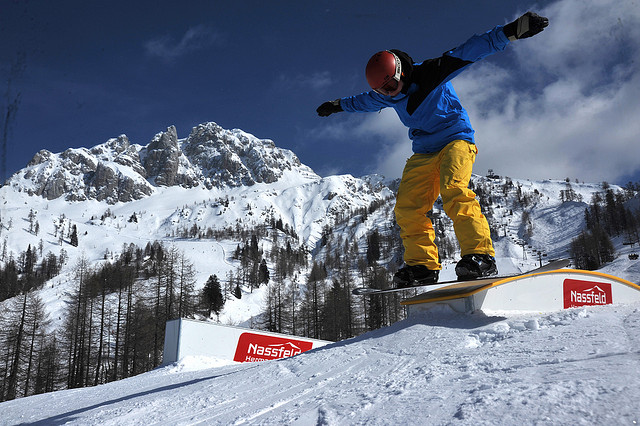What is the historical significance of this snowboarding location? This snowboarding location holds a rich history dating back to the ancient tribes that once called these mountains home. The steep, snow-covered slopes are believed to be enchanted, used for centuries as sacred grounds where warriors would train and compete in trials of endurance and bravery. Over time, the tradition evolved into more modern sports, with adventurous souls flocking here to carve their legacy into the storied peaks. Today, it remains a revered spot for snowboarding enthusiasts, symbolizing a bridge between ancient lore and contemporary athleticism. 